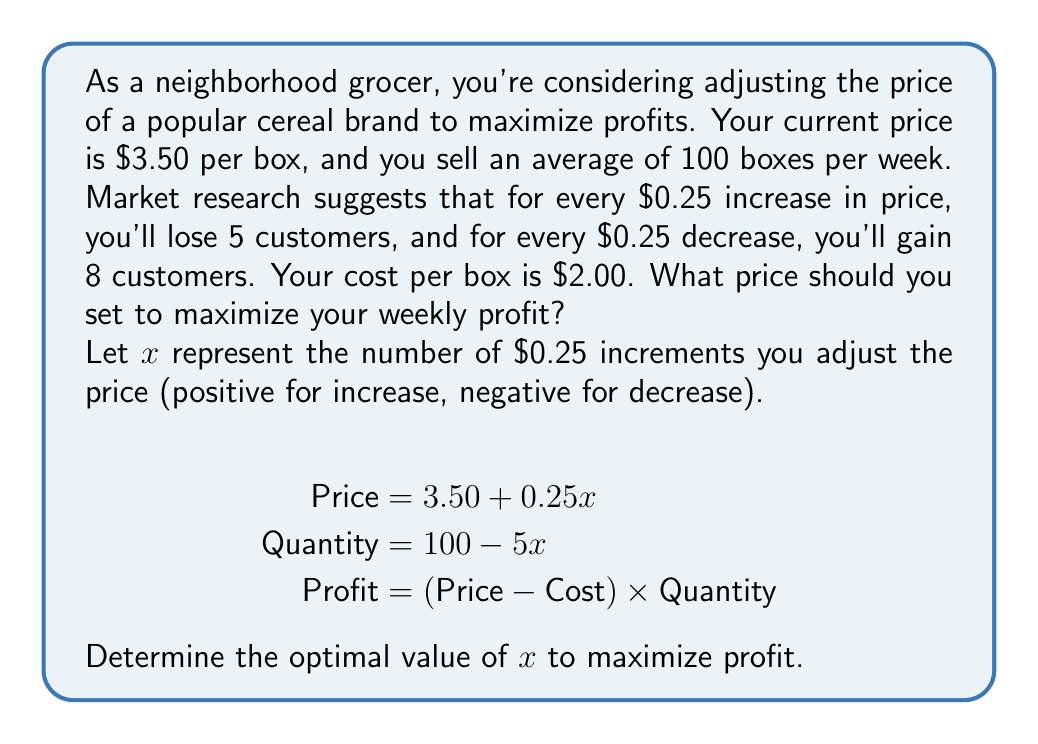Solve this math problem. Let's approach this step-by-step:

1) First, let's express the profit function in terms of $x$:

   $$\text{Profit} = (3.50 + 0.25x - 2.00)(100 - 5x)$$

2) Expand this expression:

   $$\text{Profit} = (1.50 + 0.25x)(100 - 5x)$$
   $$= 150 - 7.5x + 25x - 1.25x^2$$
   $$= 150 + 17.5x - 1.25x^2$$

3) To find the maximum profit, we need to find where the derivative of this function equals zero:

   $$\frac{d(\text{Profit})}{dx} = 17.5 - 2.5x$$

4) Set this equal to zero and solve for $x$:

   $$17.5 - 2.5x = 0$$
   $$-2.5x = -17.5$$
   $$x = 7$$

5) The second derivative is negative $(-2.5)$, confirming this is a maximum.

6) Since $x = 7$, this means we should increase the price by $7 \times $0.25 = $1.75.

7) The new optimal price is therefore $3.50 + $1.75 = $5.25.

8) Let's verify the new quantity and profit:

   New quantity: $100 - 5(7) = 65$ boxes
   New profit: $(5.25 - 2.00) \times 65 = $211.25$

   This is indeed higher than the original profit: $(3.50 - 2.00) \times 100 = $150$
Answer: $5.25 per box 